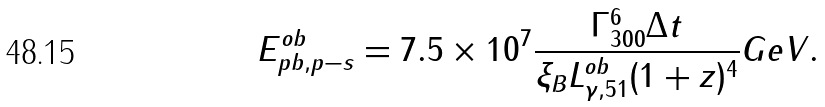<formula> <loc_0><loc_0><loc_500><loc_500>E ^ { o b } _ { p b , p - s } = 7 . 5 \times 1 0 ^ { 7 } \frac { \Gamma ^ { 6 } _ { 3 0 0 } \Delta t } { \xi _ { B } L ^ { o b } _ { \gamma , 5 1 } ( 1 + z ) ^ { 4 } } G e V .</formula> 